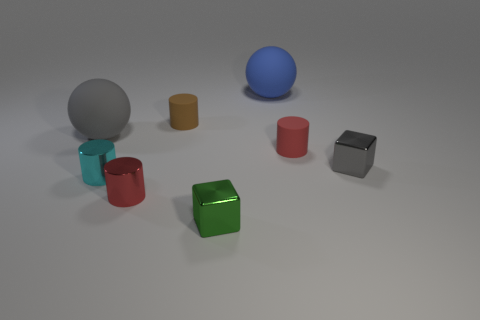The small brown object that is made of the same material as the blue thing is what shape?
Your response must be concise. Cylinder. How many other red objects are the same shape as the red shiny thing?
Ensure brevity in your answer.  1. The sphere that is the same material as the large gray object is what size?
Provide a succinct answer. Large. Are there any green blocks that are on the left side of the large matte ball behind the large rubber sphere on the left side of the green object?
Provide a succinct answer. Yes. There is a rubber sphere that is behind the gray matte sphere; does it have the same size as the red metal object?
Your response must be concise. No. How many gray shiny things have the same size as the cyan thing?
Provide a succinct answer. 1. The small gray metal object has what shape?
Offer a terse response. Cube. Is the number of red matte things behind the tiny green cube greater than the number of big blue rubber cylinders?
Your answer should be compact. Yes. Do the red shiny thing and the gray object to the left of the small gray object have the same shape?
Provide a short and direct response. No. Is there a brown matte sphere?
Offer a very short reply. No. 